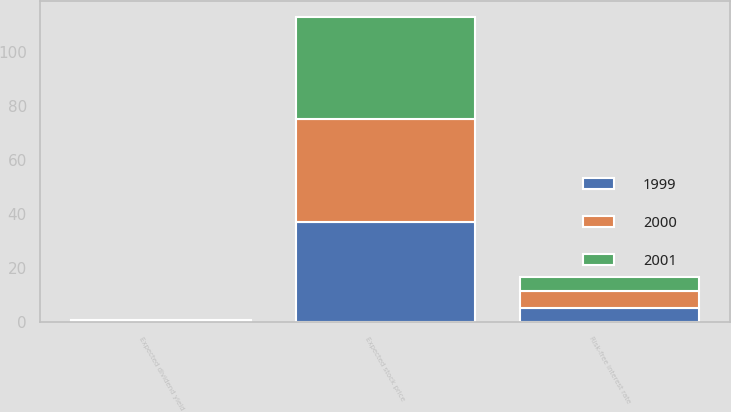<chart> <loc_0><loc_0><loc_500><loc_500><stacked_bar_chart><ecel><fcel>Risk-free interest rate<fcel>Expected dividend yield<fcel>Expected stock price<nl><fcel>2001<fcel>4.99<fcel>0.15<fcel>38<nl><fcel>1999<fcel>5.17<fcel>0.26<fcel>37<nl><fcel>2000<fcel>6.46<fcel>0.29<fcel>38<nl></chart> 